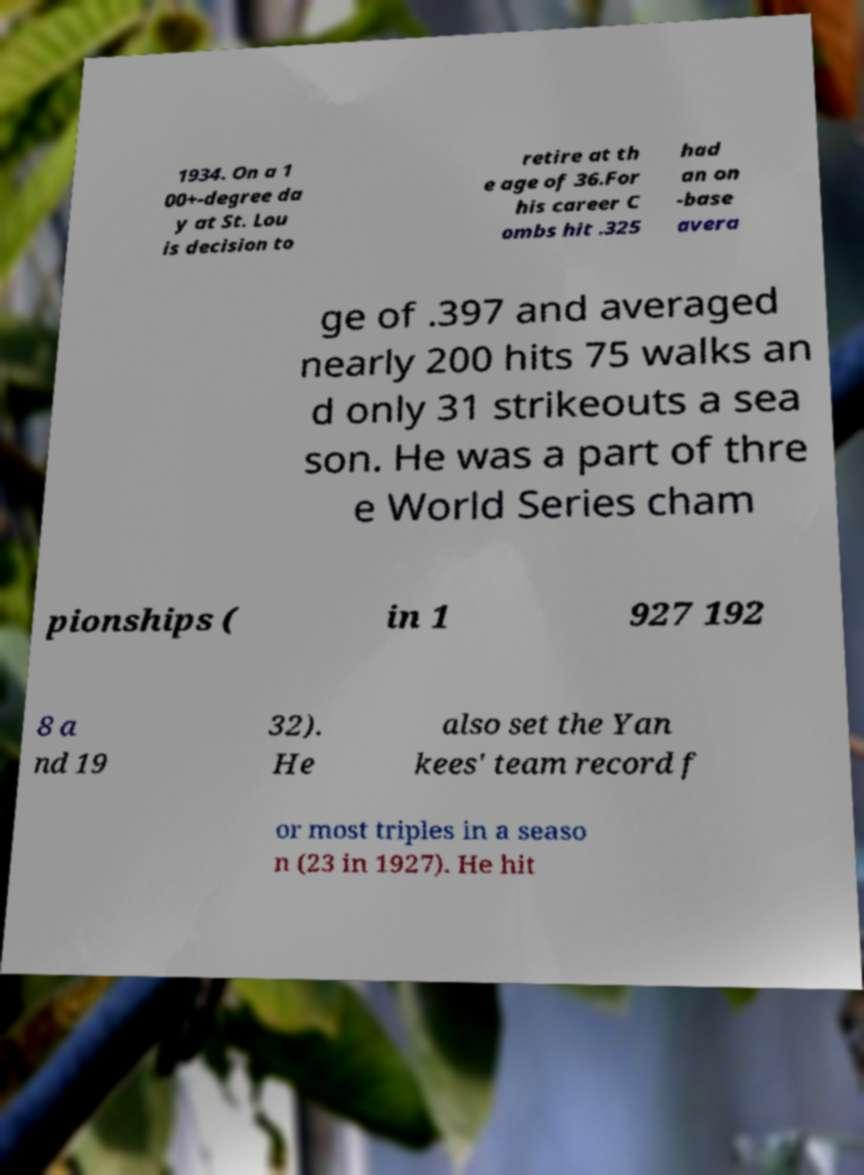Please read and relay the text visible in this image. What does it say? 1934. On a 1 00+-degree da y at St. Lou is decision to retire at th e age of 36.For his career C ombs hit .325 had an on -base avera ge of .397 and averaged nearly 200 hits 75 walks an d only 31 strikeouts a sea son. He was a part of thre e World Series cham pionships ( in 1 927 192 8 a nd 19 32). He also set the Yan kees' team record f or most triples in a seaso n (23 in 1927). He hit 